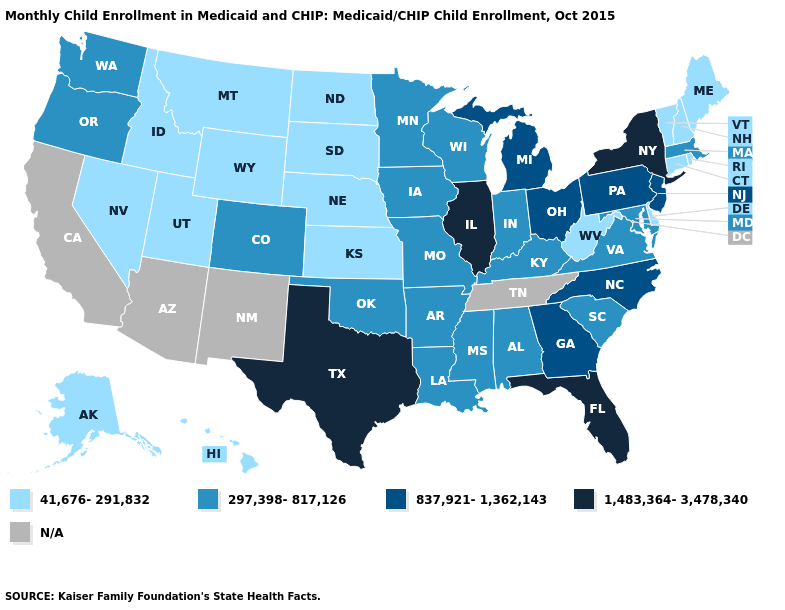Does the map have missing data?
Be succinct. Yes. Does Connecticut have the lowest value in the USA?
Quick response, please. Yes. Does Maryland have the lowest value in the USA?
Concise answer only. No. Does the first symbol in the legend represent the smallest category?
Give a very brief answer. Yes. What is the value of Florida?
Concise answer only. 1,483,364-3,478,340. What is the lowest value in states that border New Jersey?
Give a very brief answer. 41,676-291,832. Does South Dakota have the lowest value in the MidWest?
Write a very short answer. Yes. Does New York have the lowest value in the Northeast?
Quick response, please. No. Does Wyoming have the lowest value in the USA?
Answer briefly. Yes. Does the first symbol in the legend represent the smallest category?
Concise answer only. Yes. How many symbols are there in the legend?
Keep it brief. 5. What is the value of Virginia?
Concise answer only. 297,398-817,126. Does Pennsylvania have the highest value in the USA?
Answer briefly. No. 